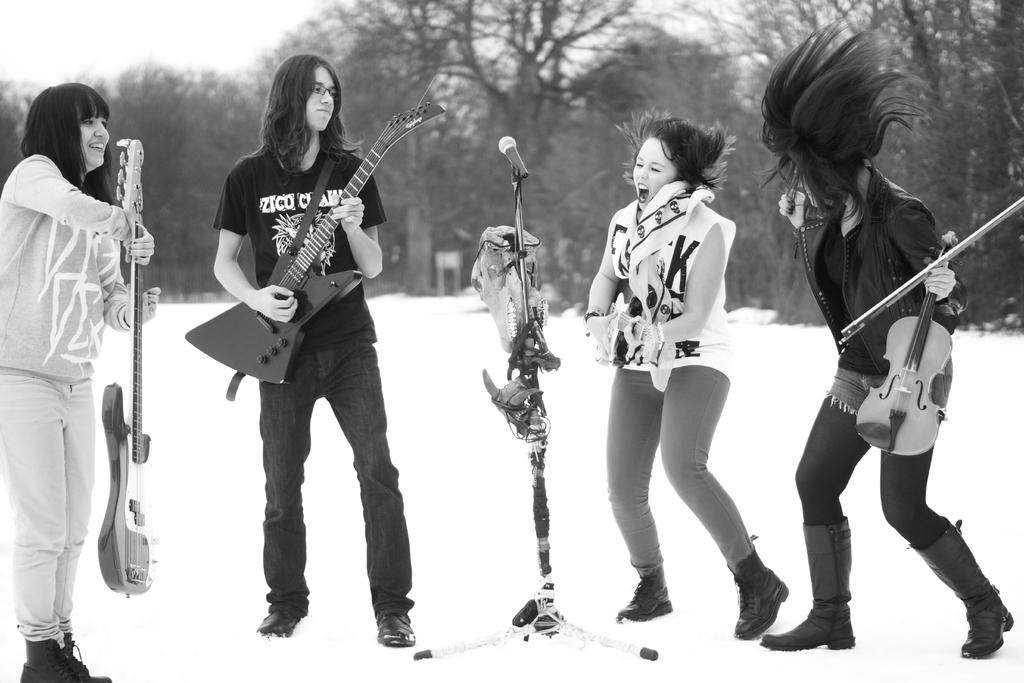How many people are in the image? There are four persons in the image. What are the persons doing in the image? The persons are standing, holding guitars, and singing. What object is in front of the persons? There is a microphone in front of the persons. What can be seen in the background of the image? There are trees in the background of the image. What type of flesh can be seen hanging from the trees in the image? There is no flesh present in the image; it only shows trees in the background. Can you tell me how many cups are visible in the image? There are no cups visible in the image. 